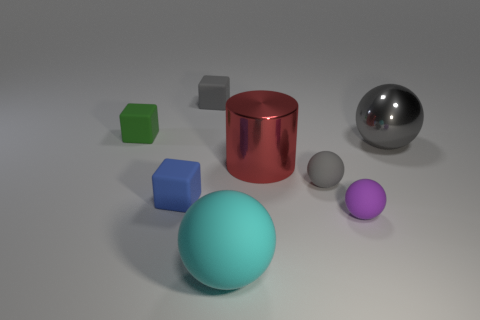Is there a large red metal thing that has the same shape as the big gray thing?
Provide a succinct answer. No. What material is the small gray thing to the left of the tiny gray matte object that is right of the tiny gray rubber object that is on the left side of the large red shiny cylinder?
Your answer should be compact. Rubber. How many other objects are there of the same size as the blue thing?
Offer a terse response. 4. What is the color of the large cylinder?
Keep it short and to the point. Red. What number of rubber things are either green blocks or small gray blocks?
Your response must be concise. 2. Are there any other things that have the same material as the cylinder?
Ensure brevity in your answer.  Yes. How big is the gray object behind the large ball behind the small ball that is behind the tiny blue thing?
Your answer should be compact. Small. There is a ball that is both in front of the large gray metallic ball and behind the tiny purple matte sphere; how big is it?
Your answer should be compact. Small. Do the large ball right of the large cyan sphere and the tiny object behind the green cube have the same color?
Provide a short and direct response. Yes. There is a small blue object; what number of tiny objects are to the left of it?
Offer a terse response. 1. 